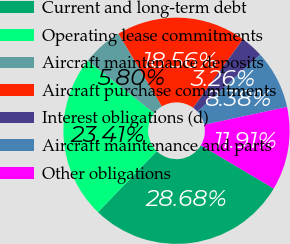Convert chart to OTSL. <chart><loc_0><loc_0><loc_500><loc_500><pie_chart><fcel>Current and long-term debt<fcel>Operating lease commitments<fcel>Aircraft maintenance deposits<fcel>Aircraft purchase commitments<fcel>Interest obligations (d)<fcel>Aircraft maintenance and parts<fcel>Other obligations<nl><fcel>28.68%<fcel>23.41%<fcel>5.8%<fcel>18.56%<fcel>3.26%<fcel>8.38%<fcel>11.91%<nl></chart> 